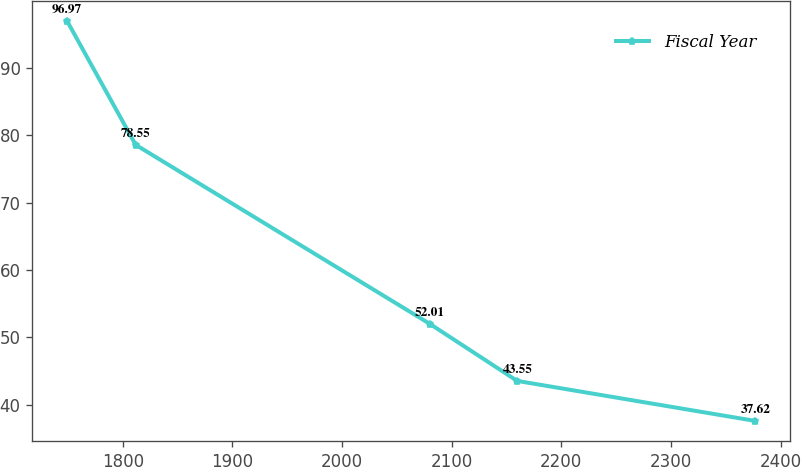<chart> <loc_0><loc_0><loc_500><loc_500><line_chart><ecel><fcel>Fiscal Year<nl><fcel>1749.03<fcel>96.97<nl><fcel>1811.81<fcel>78.55<nl><fcel>2080.03<fcel>52.01<nl><fcel>2159.72<fcel>43.55<nl><fcel>2376.85<fcel>37.62<nl></chart> 